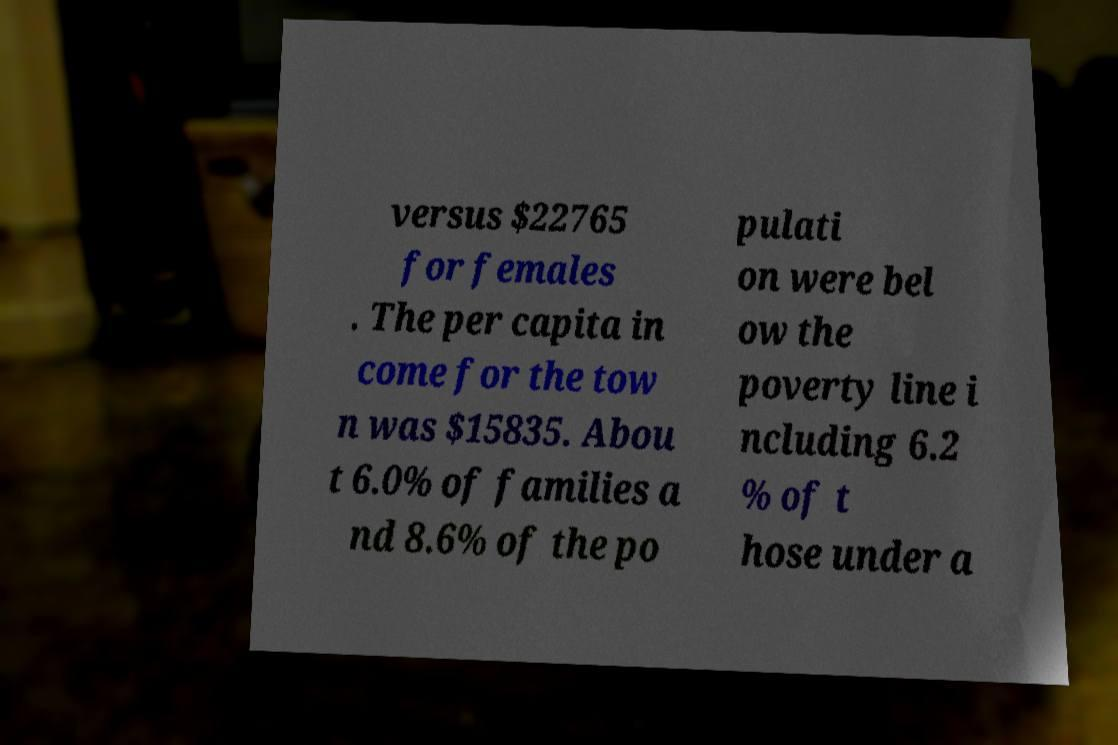Could you assist in decoding the text presented in this image and type it out clearly? versus $22765 for females . The per capita in come for the tow n was $15835. Abou t 6.0% of families a nd 8.6% of the po pulati on were bel ow the poverty line i ncluding 6.2 % of t hose under a 